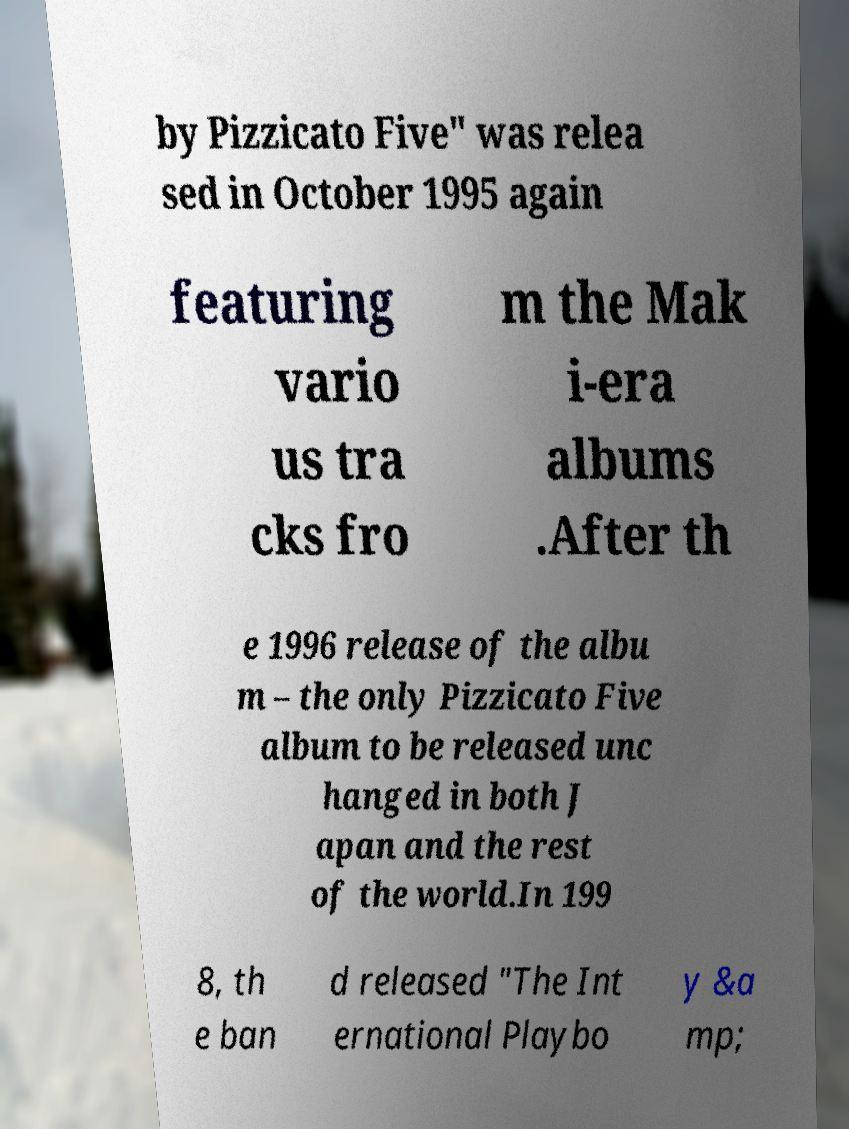Could you assist in decoding the text presented in this image and type it out clearly? by Pizzicato Five" was relea sed in October 1995 again featuring vario us tra cks fro m the Mak i-era albums .After th e 1996 release of the albu m – the only Pizzicato Five album to be released unc hanged in both J apan and the rest of the world.In 199 8, th e ban d released "The Int ernational Playbo y &a mp; 